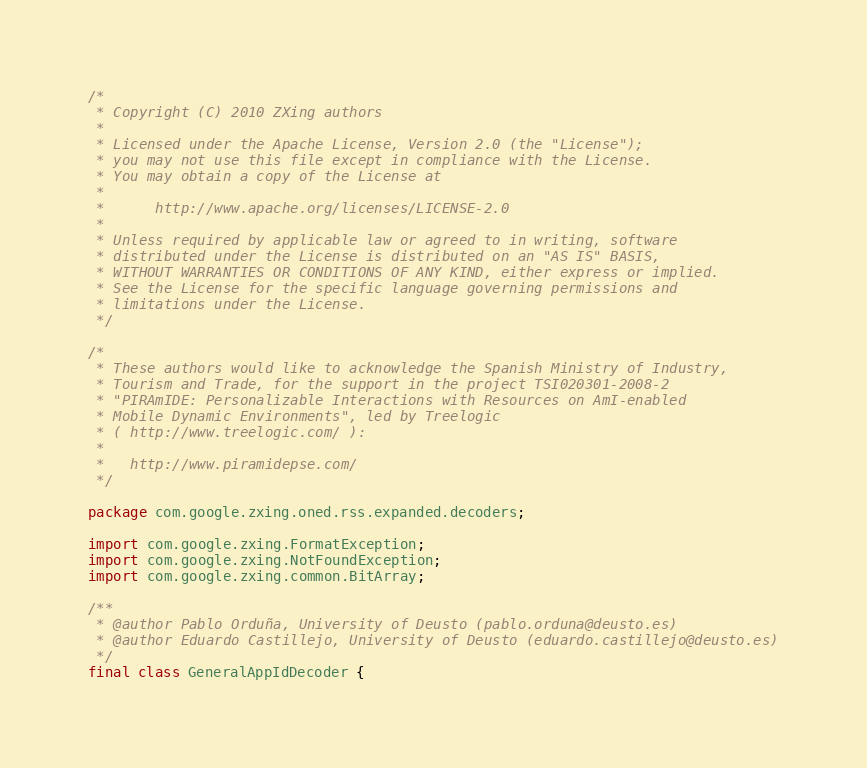<code> <loc_0><loc_0><loc_500><loc_500><_Java_>/*
 * Copyright (C) 2010 ZXing authors
 *
 * Licensed under the Apache License, Version 2.0 (the "License");
 * you may not use this file except in compliance with the License.
 * You may obtain a copy of the License at
 *
 *      http://www.apache.org/licenses/LICENSE-2.0
 *
 * Unless required by applicable law or agreed to in writing, software
 * distributed under the License is distributed on an "AS IS" BASIS,
 * WITHOUT WARRANTIES OR CONDITIONS OF ANY KIND, either express or implied.
 * See the License for the specific language governing permissions and
 * limitations under the License.
 */

/*
 * These authors would like to acknowledge the Spanish Ministry of Industry,
 * Tourism and Trade, for the support in the project TSI020301-2008-2
 * "PIRAmIDE: Personalizable Interactions with Resources on AmI-enabled
 * Mobile Dynamic Environments", led by Treelogic
 * ( http://www.treelogic.com/ ):
 *
 *   http://www.piramidepse.com/
 */

package com.google.zxing.oned.rss.expanded.decoders;

import com.google.zxing.FormatException;
import com.google.zxing.NotFoundException;
import com.google.zxing.common.BitArray;

/**
 * @author Pablo Orduña, University of Deusto (pablo.orduna@deusto.es)
 * @author Eduardo Castillejo, University of Deusto (eduardo.castillejo@deusto.es)
 */
final class GeneralAppIdDecoder {
</code> 